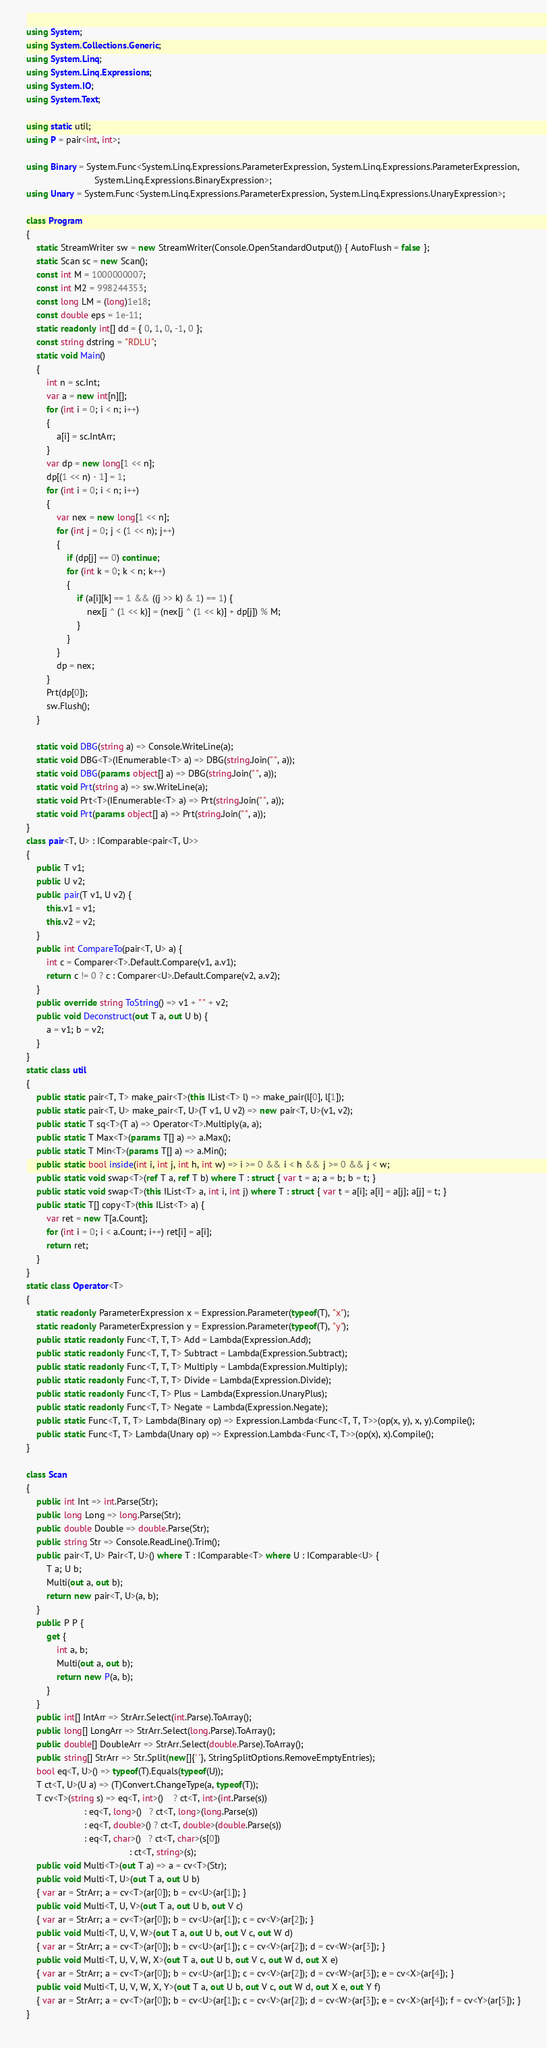<code> <loc_0><loc_0><loc_500><loc_500><_C#_>using System;
using System.Collections.Generic;
using System.Linq;
using System.Linq.Expressions;
using System.IO;
using System.Text;

using static util;
using P = pair<int, int>;

using Binary = System.Func<System.Linq.Expressions.ParameterExpression, System.Linq.Expressions.ParameterExpression,
                           System.Linq.Expressions.BinaryExpression>;
using Unary = System.Func<System.Linq.Expressions.ParameterExpression, System.Linq.Expressions.UnaryExpression>;

class Program
{
    static StreamWriter sw = new StreamWriter(Console.OpenStandardOutput()) { AutoFlush = false };
    static Scan sc = new Scan();
    const int M = 1000000007;
    const int M2 = 998244353;
    const long LM = (long)1e18;
    const double eps = 1e-11;
    static readonly int[] dd = { 0, 1, 0, -1, 0 };
    const string dstring = "RDLU";
    static void Main()
    {
        int n = sc.Int;
        var a = new int[n][];
        for (int i = 0; i < n; i++)
        {
            a[i] = sc.IntArr;
        }
        var dp = new long[1 << n];
        dp[(1 << n) - 1] = 1;
        for (int i = 0; i < n; i++)
        {
            var nex = new long[1 << n];
            for (int j = 0; j < (1 << n); j++)
            {
                if (dp[j] == 0) continue;
                for (int k = 0; k < n; k++)
                {
                    if (a[i][k] == 1 && ((j >> k) & 1) == 1) {
                        nex[j ^ (1 << k)] = (nex[j ^ (1 << k)] + dp[j]) % M;
                    }
                }
            }
            dp = nex;
        }
        Prt(dp[0]);
        sw.Flush();
    }

    static void DBG(string a) => Console.WriteLine(a);
    static void DBG<T>(IEnumerable<T> a) => DBG(string.Join(" ", a));
    static void DBG(params object[] a) => DBG(string.Join(" ", a));
    static void Prt(string a) => sw.WriteLine(a);
    static void Prt<T>(IEnumerable<T> a) => Prt(string.Join(" ", a));
    static void Prt(params object[] a) => Prt(string.Join(" ", a));
}
class pair<T, U> : IComparable<pair<T, U>>
{
    public T v1;
    public U v2;
    public pair(T v1, U v2) {
        this.v1 = v1;
        this.v2 = v2;
    }
    public int CompareTo(pair<T, U> a) {
        int c = Comparer<T>.Default.Compare(v1, a.v1);
        return c != 0 ? c : Comparer<U>.Default.Compare(v2, a.v2);
    }
    public override string ToString() => v1 + " " + v2;
    public void Deconstruct(out T a, out U b) {
        a = v1; b = v2;
    }
}
static class util
{
    public static pair<T, T> make_pair<T>(this IList<T> l) => make_pair(l[0], l[1]);
    public static pair<T, U> make_pair<T, U>(T v1, U v2) => new pair<T, U>(v1, v2);
    public static T sq<T>(T a) => Operator<T>.Multiply(a, a);
    public static T Max<T>(params T[] a) => a.Max();
    public static T Min<T>(params T[] a) => a.Min();
    public static bool inside(int i, int j, int h, int w) => i >= 0 && i < h && j >= 0 && j < w;
    public static void swap<T>(ref T a, ref T b) where T : struct { var t = a; a = b; b = t; }
    public static void swap<T>(this IList<T> a, int i, int j) where T : struct { var t = a[i]; a[i] = a[j]; a[j] = t; }
    public static T[] copy<T>(this IList<T> a) {
        var ret = new T[a.Count];
        for (int i = 0; i < a.Count; i++) ret[i] = a[i];
        return ret;
    }
}
static class Operator<T>
{
    static readonly ParameterExpression x = Expression.Parameter(typeof(T), "x");
    static readonly ParameterExpression y = Expression.Parameter(typeof(T), "y");
    public static readonly Func<T, T, T> Add = Lambda(Expression.Add);
    public static readonly Func<T, T, T> Subtract = Lambda(Expression.Subtract);
    public static readonly Func<T, T, T> Multiply = Lambda(Expression.Multiply);
    public static readonly Func<T, T, T> Divide = Lambda(Expression.Divide);
    public static readonly Func<T, T> Plus = Lambda(Expression.UnaryPlus);
    public static readonly Func<T, T> Negate = Lambda(Expression.Negate);
    public static Func<T, T, T> Lambda(Binary op) => Expression.Lambda<Func<T, T, T>>(op(x, y), x, y).Compile();
    public static Func<T, T> Lambda(Unary op) => Expression.Lambda<Func<T, T>>(op(x), x).Compile();
}

class Scan
{
    public int Int => int.Parse(Str);
    public long Long => long.Parse(Str);
    public double Double => double.Parse(Str);
    public string Str => Console.ReadLine().Trim();
    public pair<T, U> Pair<T, U>() where T : IComparable<T> where U : IComparable<U> {
        T a; U b;
        Multi(out a, out b);
        return new pair<T, U>(a, b);
    }
    public P P {
        get {
            int a, b;
            Multi(out a, out b);
            return new P(a, b);
        }
    }
    public int[] IntArr => StrArr.Select(int.Parse).ToArray();
    public long[] LongArr => StrArr.Select(long.Parse).ToArray();
    public double[] DoubleArr => StrArr.Select(double.Parse).ToArray();
    public string[] StrArr => Str.Split(new[]{' '}, StringSplitOptions.RemoveEmptyEntries);
    bool eq<T, U>() => typeof(T).Equals(typeof(U));
    T ct<T, U>(U a) => (T)Convert.ChangeType(a, typeof(T));
    T cv<T>(string s) => eq<T, int>()    ? ct<T, int>(int.Parse(s))
                       : eq<T, long>()   ? ct<T, long>(long.Parse(s))
                       : eq<T, double>() ? ct<T, double>(double.Parse(s))
                       : eq<T, char>()   ? ct<T, char>(s[0])
                                         : ct<T, string>(s);
    public void Multi<T>(out T a) => a = cv<T>(Str);
    public void Multi<T, U>(out T a, out U b)
    { var ar = StrArr; a = cv<T>(ar[0]); b = cv<U>(ar[1]); }
    public void Multi<T, U, V>(out T a, out U b, out V c)
    { var ar = StrArr; a = cv<T>(ar[0]); b = cv<U>(ar[1]); c = cv<V>(ar[2]); }
    public void Multi<T, U, V, W>(out T a, out U b, out V c, out W d)
    { var ar = StrArr; a = cv<T>(ar[0]); b = cv<U>(ar[1]); c = cv<V>(ar[2]); d = cv<W>(ar[3]); }
    public void Multi<T, U, V, W, X>(out T a, out U b, out V c, out W d, out X e)
    { var ar = StrArr; a = cv<T>(ar[0]); b = cv<U>(ar[1]); c = cv<V>(ar[2]); d = cv<W>(ar[3]); e = cv<X>(ar[4]); }
    public void Multi<T, U, V, W, X, Y>(out T a, out U b, out V c, out W d, out X e, out Y f)
    { var ar = StrArr; a = cv<T>(ar[0]); b = cv<U>(ar[1]); c = cv<V>(ar[2]); d = cv<W>(ar[3]); e = cv<X>(ar[4]); f = cv<Y>(ar[5]); }
}
</code> 